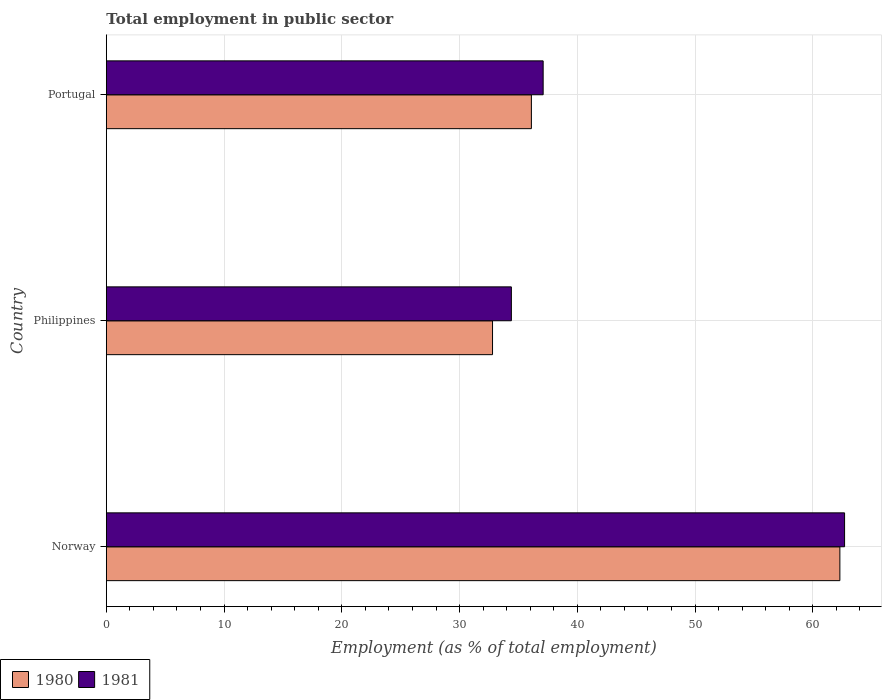How many groups of bars are there?
Give a very brief answer. 3. Are the number of bars on each tick of the Y-axis equal?
Offer a terse response. Yes. How many bars are there on the 3rd tick from the top?
Give a very brief answer. 2. How many bars are there on the 3rd tick from the bottom?
Your answer should be compact. 2. In how many cases, is the number of bars for a given country not equal to the number of legend labels?
Offer a terse response. 0. What is the employment in public sector in 1981 in Norway?
Offer a terse response. 62.7. Across all countries, what is the maximum employment in public sector in 1980?
Make the answer very short. 62.3. Across all countries, what is the minimum employment in public sector in 1980?
Make the answer very short. 32.8. What is the total employment in public sector in 1981 in the graph?
Your answer should be compact. 134.2. What is the difference between the employment in public sector in 1980 in Philippines and that in Portugal?
Offer a terse response. -3.3. What is the difference between the employment in public sector in 1980 in Philippines and the employment in public sector in 1981 in Norway?
Your answer should be very brief. -29.9. What is the average employment in public sector in 1980 per country?
Provide a short and direct response. 43.73. What is the difference between the employment in public sector in 1981 and employment in public sector in 1980 in Norway?
Your answer should be very brief. 0.4. What is the ratio of the employment in public sector in 1981 in Philippines to that in Portugal?
Keep it short and to the point. 0.93. Is the difference between the employment in public sector in 1981 in Norway and Philippines greater than the difference between the employment in public sector in 1980 in Norway and Philippines?
Offer a very short reply. No. What is the difference between the highest and the second highest employment in public sector in 1981?
Offer a very short reply. 25.6. What is the difference between the highest and the lowest employment in public sector in 1980?
Your answer should be compact. 29.5. What does the 1st bar from the top in Norway represents?
Give a very brief answer. 1981. What does the 1st bar from the bottom in Philippines represents?
Make the answer very short. 1980. How many bars are there?
Your answer should be compact. 6. Are all the bars in the graph horizontal?
Keep it short and to the point. Yes. How many countries are there in the graph?
Provide a succinct answer. 3. Are the values on the major ticks of X-axis written in scientific E-notation?
Offer a terse response. No. Does the graph contain grids?
Give a very brief answer. Yes. What is the title of the graph?
Offer a terse response. Total employment in public sector. What is the label or title of the X-axis?
Your response must be concise. Employment (as % of total employment). What is the label or title of the Y-axis?
Offer a very short reply. Country. What is the Employment (as % of total employment) of 1980 in Norway?
Offer a very short reply. 62.3. What is the Employment (as % of total employment) of 1981 in Norway?
Keep it short and to the point. 62.7. What is the Employment (as % of total employment) of 1980 in Philippines?
Offer a very short reply. 32.8. What is the Employment (as % of total employment) of 1981 in Philippines?
Ensure brevity in your answer.  34.4. What is the Employment (as % of total employment) in 1980 in Portugal?
Give a very brief answer. 36.1. What is the Employment (as % of total employment) of 1981 in Portugal?
Your response must be concise. 37.1. Across all countries, what is the maximum Employment (as % of total employment) in 1980?
Give a very brief answer. 62.3. Across all countries, what is the maximum Employment (as % of total employment) of 1981?
Your answer should be compact. 62.7. Across all countries, what is the minimum Employment (as % of total employment) in 1980?
Your response must be concise. 32.8. Across all countries, what is the minimum Employment (as % of total employment) in 1981?
Offer a very short reply. 34.4. What is the total Employment (as % of total employment) in 1980 in the graph?
Make the answer very short. 131.2. What is the total Employment (as % of total employment) in 1981 in the graph?
Give a very brief answer. 134.2. What is the difference between the Employment (as % of total employment) of 1980 in Norway and that in Philippines?
Ensure brevity in your answer.  29.5. What is the difference between the Employment (as % of total employment) in 1981 in Norway and that in Philippines?
Provide a short and direct response. 28.3. What is the difference between the Employment (as % of total employment) in 1980 in Norway and that in Portugal?
Your answer should be compact. 26.2. What is the difference between the Employment (as % of total employment) in 1981 in Norway and that in Portugal?
Provide a succinct answer. 25.6. What is the difference between the Employment (as % of total employment) in 1981 in Philippines and that in Portugal?
Offer a very short reply. -2.7. What is the difference between the Employment (as % of total employment) in 1980 in Norway and the Employment (as % of total employment) in 1981 in Philippines?
Your answer should be compact. 27.9. What is the difference between the Employment (as % of total employment) in 1980 in Norway and the Employment (as % of total employment) in 1981 in Portugal?
Make the answer very short. 25.2. What is the average Employment (as % of total employment) in 1980 per country?
Offer a very short reply. 43.73. What is the average Employment (as % of total employment) of 1981 per country?
Make the answer very short. 44.73. What is the difference between the Employment (as % of total employment) in 1980 and Employment (as % of total employment) in 1981 in Norway?
Provide a succinct answer. -0.4. What is the difference between the Employment (as % of total employment) in 1980 and Employment (as % of total employment) in 1981 in Philippines?
Give a very brief answer. -1.6. What is the difference between the Employment (as % of total employment) in 1980 and Employment (as % of total employment) in 1981 in Portugal?
Ensure brevity in your answer.  -1. What is the ratio of the Employment (as % of total employment) of 1980 in Norway to that in Philippines?
Ensure brevity in your answer.  1.9. What is the ratio of the Employment (as % of total employment) in 1981 in Norway to that in Philippines?
Provide a short and direct response. 1.82. What is the ratio of the Employment (as % of total employment) of 1980 in Norway to that in Portugal?
Make the answer very short. 1.73. What is the ratio of the Employment (as % of total employment) in 1981 in Norway to that in Portugal?
Offer a very short reply. 1.69. What is the ratio of the Employment (as % of total employment) of 1980 in Philippines to that in Portugal?
Provide a short and direct response. 0.91. What is the ratio of the Employment (as % of total employment) of 1981 in Philippines to that in Portugal?
Offer a very short reply. 0.93. What is the difference between the highest and the second highest Employment (as % of total employment) of 1980?
Offer a terse response. 26.2. What is the difference between the highest and the second highest Employment (as % of total employment) in 1981?
Your answer should be very brief. 25.6. What is the difference between the highest and the lowest Employment (as % of total employment) of 1980?
Provide a short and direct response. 29.5. What is the difference between the highest and the lowest Employment (as % of total employment) of 1981?
Ensure brevity in your answer.  28.3. 